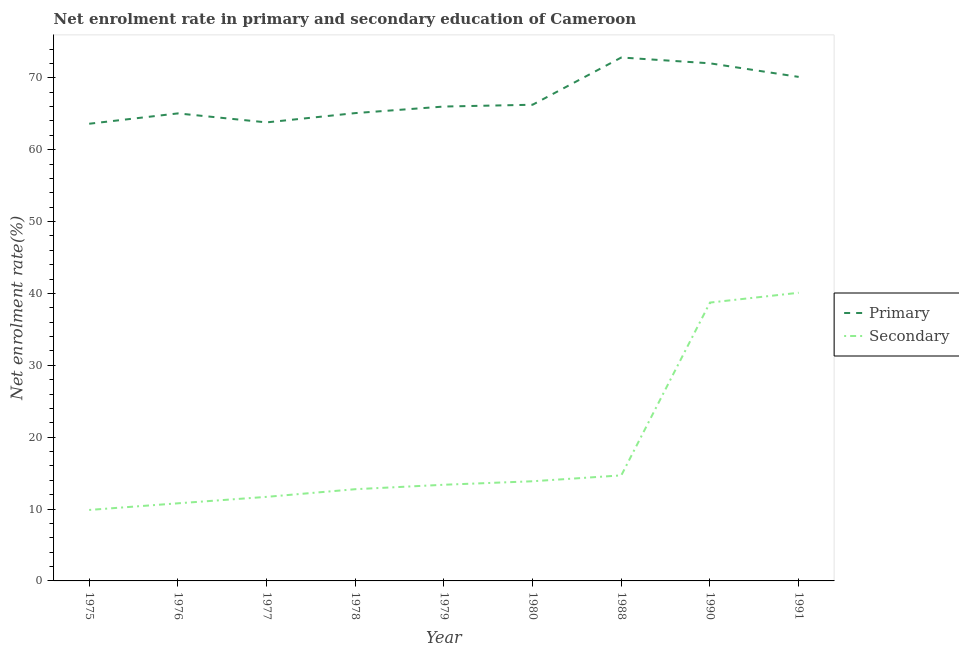How many different coloured lines are there?
Give a very brief answer. 2. Does the line corresponding to enrollment rate in secondary education intersect with the line corresponding to enrollment rate in primary education?
Make the answer very short. No. Is the number of lines equal to the number of legend labels?
Provide a succinct answer. Yes. What is the enrollment rate in secondary education in 1979?
Keep it short and to the point. 13.38. Across all years, what is the maximum enrollment rate in secondary education?
Ensure brevity in your answer.  40.09. Across all years, what is the minimum enrollment rate in secondary education?
Provide a short and direct response. 9.88. In which year was the enrollment rate in primary education minimum?
Keep it short and to the point. 1975. What is the total enrollment rate in secondary education in the graph?
Offer a terse response. 165.89. What is the difference between the enrollment rate in primary education in 1988 and that in 1990?
Keep it short and to the point. 0.81. What is the difference between the enrollment rate in primary education in 1978 and the enrollment rate in secondary education in 1980?
Ensure brevity in your answer.  51.23. What is the average enrollment rate in primary education per year?
Offer a very short reply. 67.2. In the year 1977, what is the difference between the enrollment rate in secondary education and enrollment rate in primary education?
Your answer should be compact. -52.1. In how many years, is the enrollment rate in primary education greater than 32 %?
Provide a succinct answer. 9. What is the ratio of the enrollment rate in primary education in 1976 to that in 1990?
Provide a succinct answer. 0.9. Is the difference between the enrollment rate in primary education in 1988 and 1990 greater than the difference between the enrollment rate in secondary education in 1988 and 1990?
Offer a terse response. Yes. What is the difference between the highest and the second highest enrollment rate in secondary education?
Offer a terse response. 1.36. What is the difference between the highest and the lowest enrollment rate in primary education?
Keep it short and to the point. 9.22. In how many years, is the enrollment rate in secondary education greater than the average enrollment rate in secondary education taken over all years?
Offer a terse response. 2. Does the enrollment rate in secondary education monotonically increase over the years?
Make the answer very short. Yes. Does the graph contain any zero values?
Keep it short and to the point. No. How are the legend labels stacked?
Your response must be concise. Vertical. What is the title of the graph?
Your answer should be compact. Net enrolment rate in primary and secondary education of Cameroon. Does "Nitrous oxide" appear as one of the legend labels in the graph?
Offer a very short reply. No. What is the label or title of the X-axis?
Offer a terse response. Year. What is the label or title of the Y-axis?
Provide a succinct answer. Net enrolment rate(%). What is the Net enrolment rate(%) in Primary in 1975?
Ensure brevity in your answer.  63.61. What is the Net enrolment rate(%) of Secondary in 1975?
Your answer should be very brief. 9.88. What is the Net enrolment rate(%) of Primary in 1976?
Provide a succinct answer. 65.05. What is the Net enrolment rate(%) of Secondary in 1976?
Keep it short and to the point. 10.8. What is the Net enrolment rate(%) in Primary in 1977?
Your response must be concise. 63.8. What is the Net enrolment rate(%) in Secondary in 1977?
Keep it short and to the point. 11.7. What is the Net enrolment rate(%) of Primary in 1978?
Your answer should be compact. 65.09. What is the Net enrolment rate(%) in Secondary in 1978?
Provide a short and direct response. 12.76. What is the Net enrolment rate(%) of Primary in 1979?
Offer a terse response. 66.01. What is the Net enrolment rate(%) in Secondary in 1979?
Offer a very short reply. 13.38. What is the Net enrolment rate(%) in Primary in 1980?
Offer a very short reply. 66.26. What is the Net enrolment rate(%) in Secondary in 1980?
Offer a terse response. 13.87. What is the Net enrolment rate(%) in Primary in 1988?
Offer a very short reply. 72.83. What is the Net enrolment rate(%) of Secondary in 1988?
Your answer should be very brief. 14.69. What is the Net enrolment rate(%) of Primary in 1990?
Ensure brevity in your answer.  72.02. What is the Net enrolment rate(%) of Secondary in 1990?
Offer a terse response. 38.73. What is the Net enrolment rate(%) of Primary in 1991?
Your answer should be compact. 70.13. What is the Net enrolment rate(%) in Secondary in 1991?
Your answer should be very brief. 40.09. Across all years, what is the maximum Net enrolment rate(%) in Primary?
Your answer should be compact. 72.83. Across all years, what is the maximum Net enrolment rate(%) in Secondary?
Offer a terse response. 40.09. Across all years, what is the minimum Net enrolment rate(%) of Primary?
Your answer should be compact. 63.61. Across all years, what is the minimum Net enrolment rate(%) in Secondary?
Give a very brief answer. 9.88. What is the total Net enrolment rate(%) of Primary in the graph?
Your response must be concise. 604.8. What is the total Net enrolment rate(%) in Secondary in the graph?
Offer a terse response. 165.89. What is the difference between the Net enrolment rate(%) of Primary in 1975 and that in 1976?
Give a very brief answer. -1.44. What is the difference between the Net enrolment rate(%) in Secondary in 1975 and that in 1976?
Provide a short and direct response. -0.92. What is the difference between the Net enrolment rate(%) of Primary in 1975 and that in 1977?
Your answer should be very brief. -0.19. What is the difference between the Net enrolment rate(%) of Secondary in 1975 and that in 1977?
Your answer should be compact. -1.82. What is the difference between the Net enrolment rate(%) of Primary in 1975 and that in 1978?
Your answer should be very brief. -1.48. What is the difference between the Net enrolment rate(%) of Secondary in 1975 and that in 1978?
Your answer should be very brief. -2.89. What is the difference between the Net enrolment rate(%) of Primary in 1975 and that in 1979?
Provide a short and direct response. -2.39. What is the difference between the Net enrolment rate(%) in Secondary in 1975 and that in 1979?
Your answer should be compact. -3.51. What is the difference between the Net enrolment rate(%) of Primary in 1975 and that in 1980?
Offer a terse response. -2.65. What is the difference between the Net enrolment rate(%) in Secondary in 1975 and that in 1980?
Your answer should be compact. -3.99. What is the difference between the Net enrolment rate(%) in Primary in 1975 and that in 1988?
Provide a succinct answer. -9.22. What is the difference between the Net enrolment rate(%) in Secondary in 1975 and that in 1988?
Your answer should be very brief. -4.81. What is the difference between the Net enrolment rate(%) in Primary in 1975 and that in 1990?
Give a very brief answer. -8.41. What is the difference between the Net enrolment rate(%) of Secondary in 1975 and that in 1990?
Your answer should be compact. -28.85. What is the difference between the Net enrolment rate(%) of Primary in 1975 and that in 1991?
Make the answer very short. -6.52. What is the difference between the Net enrolment rate(%) in Secondary in 1975 and that in 1991?
Ensure brevity in your answer.  -30.22. What is the difference between the Net enrolment rate(%) in Primary in 1976 and that in 1977?
Your answer should be very brief. 1.25. What is the difference between the Net enrolment rate(%) of Secondary in 1976 and that in 1977?
Offer a very short reply. -0.9. What is the difference between the Net enrolment rate(%) in Primary in 1976 and that in 1978?
Give a very brief answer. -0.04. What is the difference between the Net enrolment rate(%) in Secondary in 1976 and that in 1978?
Provide a succinct answer. -1.96. What is the difference between the Net enrolment rate(%) of Primary in 1976 and that in 1979?
Ensure brevity in your answer.  -0.95. What is the difference between the Net enrolment rate(%) of Secondary in 1976 and that in 1979?
Your answer should be compact. -2.58. What is the difference between the Net enrolment rate(%) in Primary in 1976 and that in 1980?
Keep it short and to the point. -1.21. What is the difference between the Net enrolment rate(%) of Secondary in 1976 and that in 1980?
Make the answer very short. -3.07. What is the difference between the Net enrolment rate(%) of Primary in 1976 and that in 1988?
Make the answer very short. -7.78. What is the difference between the Net enrolment rate(%) of Secondary in 1976 and that in 1988?
Keep it short and to the point. -3.89. What is the difference between the Net enrolment rate(%) of Primary in 1976 and that in 1990?
Offer a very short reply. -6.97. What is the difference between the Net enrolment rate(%) of Secondary in 1976 and that in 1990?
Provide a short and direct response. -27.93. What is the difference between the Net enrolment rate(%) of Primary in 1976 and that in 1991?
Your answer should be compact. -5.08. What is the difference between the Net enrolment rate(%) in Secondary in 1976 and that in 1991?
Ensure brevity in your answer.  -29.3. What is the difference between the Net enrolment rate(%) of Primary in 1977 and that in 1978?
Provide a succinct answer. -1.29. What is the difference between the Net enrolment rate(%) in Secondary in 1977 and that in 1978?
Ensure brevity in your answer.  -1.07. What is the difference between the Net enrolment rate(%) of Primary in 1977 and that in 1979?
Your response must be concise. -2.21. What is the difference between the Net enrolment rate(%) in Secondary in 1977 and that in 1979?
Give a very brief answer. -1.68. What is the difference between the Net enrolment rate(%) in Primary in 1977 and that in 1980?
Give a very brief answer. -2.46. What is the difference between the Net enrolment rate(%) in Secondary in 1977 and that in 1980?
Provide a short and direct response. -2.17. What is the difference between the Net enrolment rate(%) in Primary in 1977 and that in 1988?
Provide a short and direct response. -9.03. What is the difference between the Net enrolment rate(%) of Secondary in 1977 and that in 1988?
Your response must be concise. -2.99. What is the difference between the Net enrolment rate(%) of Primary in 1977 and that in 1990?
Ensure brevity in your answer.  -8.22. What is the difference between the Net enrolment rate(%) of Secondary in 1977 and that in 1990?
Offer a very short reply. -27.03. What is the difference between the Net enrolment rate(%) in Primary in 1977 and that in 1991?
Ensure brevity in your answer.  -6.33. What is the difference between the Net enrolment rate(%) in Secondary in 1977 and that in 1991?
Offer a terse response. -28.4. What is the difference between the Net enrolment rate(%) in Primary in 1978 and that in 1979?
Provide a short and direct response. -0.91. What is the difference between the Net enrolment rate(%) of Secondary in 1978 and that in 1979?
Your answer should be very brief. -0.62. What is the difference between the Net enrolment rate(%) of Primary in 1978 and that in 1980?
Offer a very short reply. -1.16. What is the difference between the Net enrolment rate(%) in Secondary in 1978 and that in 1980?
Provide a succinct answer. -1.11. What is the difference between the Net enrolment rate(%) in Primary in 1978 and that in 1988?
Keep it short and to the point. -7.74. What is the difference between the Net enrolment rate(%) in Secondary in 1978 and that in 1988?
Offer a terse response. -1.92. What is the difference between the Net enrolment rate(%) in Primary in 1978 and that in 1990?
Provide a short and direct response. -6.93. What is the difference between the Net enrolment rate(%) in Secondary in 1978 and that in 1990?
Keep it short and to the point. -25.97. What is the difference between the Net enrolment rate(%) of Primary in 1978 and that in 1991?
Keep it short and to the point. -5.04. What is the difference between the Net enrolment rate(%) in Secondary in 1978 and that in 1991?
Your response must be concise. -27.33. What is the difference between the Net enrolment rate(%) in Primary in 1979 and that in 1980?
Provide a short and direct response. -0.25. What is the difference between the Net enrolment rate(%) in Secondary in 1979 and that in 1980?
Make the answer very short. -0.49. What is the difference between the Net enrolment rate(%) in Primary in 1979 and that in 1988?
Offer a very short reply. -6.82. What is the difference between the Net enrolment rate(%) of Secondary in 1979 and that in 1988?
Your answer should be very brief. -1.31. What is the difference between the Net enrolment rate(%) in Primary in 1979 and that in 1990?
Your answer should be compact. -6.01. What is the difference between the Net enrolment rate(%) of Secondary in 1979 and that in 1990?
Offer a very short reply. -25.35. What is the difference between the Net enrolment rate(%) of Primary in 1979 and that in 1991?
Give a very brief answer. -4.12. What is the difference between the Net enrolment rate(%) in Secondary in 1979 and that in 1991?
Ensure brevity in your answer.  -26.71. What is the difference between the Net enrolment rate(%) in Primary in 1980 and that in 1988?
Your answer should be very brief. -6.57. What is the difference between the Net enrolment rate(%) in Secondary in 1980 and that in 1988?
Your answer should be compact. -0.82. What is the difference between the Net enrolment rate(%) in Primary in 1980 and that in 1990?
Provide a succinct answer. -5.76. What is the difference between the Net enrolment rate(%) in Secondary in 1980 and that in 1990?
Give a very brief answer. -24.86. What is the difference between the Net enrolment rate(%) of Primary in 1980 and that in 1991?
Provide a short and direct response. -3.87. What is the difference between the Net enrolment rate(%) in Secondary in 1980 and that in 1991?
Offer a terse response. -26.23. What is the difference between the Net enrolment rate(%) in Primary in 1988 and that in 1990?
Offer a terse response. 0.81. What is the difference between the Net enrolment rate(%) of Secondary in 1988 and that in 1990?
Your answer should be compact. -24.04. What is the difference between the Net enrolment rate(%) in Primary in 1988 and that in 1991?
Give a very brief answer. 2.7. What is the difference between the Net enrolment rate(%) of Secondary in 1988 and that in 1991?
Your response must be concise. -25.41. What is the difference between the Net enrolment rate(%) of Primary in 1990 and that in 1991?
Ensure brevity in your answer.  1.89. What is the difference between the Net enrolment rate(%) of Secondary in 1990 and that in 1991?
Your answer should be compact. -1.36. What is the difference between the Net enrolment rate(%) in Primary in 1975 and the Net enrolment rate(%) in Secondary in 1976?
Keep it short and to the point. 52.81. What is the difference between the Net enrolment rate(%) of Primary in 1975 and the Net enrolment rate(%) of Secondary in 1977?
Provide a short and direct response. 51.92. What is the difference between the Net enrolment rate(%) of Primary in 1975 and the Net enrolment rate(%) of Secondary in 1978?
Make the answer very short. 50.85. What is the difference between the Net enrolment rate(%) of Primary in 1975 and the Net enrolment rate(%) of Secondary in 1979?
Ensure brevity in your answer.  50.23. What is the difference between the Net enrolment rate(%) of Primary in 1975 and the Net enrolment rate(%) of Secondary in 1980?
Your answer should be very brief. 49.74. What is the difference between the Net enrolment rate(%) of Primary in 1975 and the Net enrolment rate(%) of Secondary in 1988?
Your answer should be compact. 48.93. What is the difference between the Net enrolment rate(%) of Primary in 1975 and the Net enrolment rate(%) of Secondary in 1990?
Provide a succinct answer. 24.88. What is the difference between the Net enrolment rate(%) in Primary in 1975 and the Net enrolment rate(%) in Secondary in 1991?
Offer a very short reply. 23.52. What is the difference between the Net enrolment rate(%) in Primary in 1976 and the Net enrolment rate(%) in Secondary in 1977?
Provide a short and direct response. 53.36. What is the difference between the Net enrolment rate(%) of Primary in 1976 and the Net enrolment rate(%) of Secondary in 1978?
Your answer should be compact. 52.29. What is the difference between the Net enrolment rate(%) in Primary in 1976 and the Net enrolment rate(%) in Secondary in 1979?
Offer a very short reply. 51.67. What is the difference between the Net enrolment rate(%) of Primary in 1976 and the Net enrolment rate(%) of Secondary in 1980?
Offer a very short reply. 51.18. What is the difference between the Net enrolment rate(%) of Primary in 1976 and the Net enrolment rate(%) of Secondary in 1988?
Provide a succinct answer. 50.37. What is the difference between the Net enrolment rate(%) in Primary in 1976 and the Net enrolment rate(%) in Secondary in 1990?
Offer a very short reply. 26.32. What is the difference between the Net enrolment rate(%) in Primary in 1976 and the Net enrolment rate(%) in Secondary in 1991?
Your answer should be compact. 24.96. What is the difference between the Net enrolment rate(%) in Primary in 1977 and the Net enrolment rate(%) in Secondary in 1978?
Make the answer very short. 51.04. What is the difference between the Net enrolment rate(%) in Primary in 1977 and the Net enrolment rate(%) in Secondary in 1979?
Your answer should be very brief. 50.42. What is the difference between the Net enrolment rate(%) in Primary in 1977 and the Net enrolment rate(%) in Secondary in 1980?
Ensure brevity in your answer.  49.93. What is the difference between the Net enrolment rate(%) of Primary in 1977 and the Net enrolment rate(%) of Secondary in 1988?
Ensure brevity in your answer.  49.11. What is the difference between the Net enrolment rate(%) in Primary in 1977 and the Net enrolment rate(%) in Secondary in 1990?
Provide a succinct answer. 25.07. What is the difference between the Net enrolment rate(%) of Primary in 1977 and the Net enrolment rate(%) of Secondary in 1991?
Provide a succinct answer. 23.71. What is the difference between the Net enrolment rate(%) in Primary in 1978 and the Net enrolment rate(%) in Secondary in 1979?
Keep it short and to the point. 51.71. What is the difference between the Net enrolment rate(%) of Primary in 1978 and the Net enrolment rate(%) of Secondary in 1980?
Offer a very short reply. 51.23. What is the difference between the Net enrolment rate(%) in Primary in 1978 and the Net enrolment rate(%) in Secondary in 1988?
Your answer should be compact. 50.41. What is the difference between the Net enrolment rate(%) of Primary in 1978 and the Net enrolment rate(%) of Secondary in 1990?
Ensure brevity in your answer.  26.36. What is the difference between the Net enrolment rate(%) in Primary in 1978 and the Net enrolment rate(%) in Secondary in 1991?
Your answer should be compact. 25. What is the difference between the Net enrolment rate(%) in Primary in 1979 and the Net enrolment rate(%) in Secondary in 1980?
Your answer should be compact. 52.14. What is the difference between the Net enrolment rate(%) in Primary in 1979 and the Net enrolment rate(%) in Secondary in 1988?
Your answer should be very brief. 51.32. What is the difference between the Net enrolment rate(%) in Primary in 1979 and the Net enrolment rate(%) in Secondary in 1990?
Your response must be concise. 27.28. What is the difference between the Net enrolment rate(%) of Primary in 1979 and the Net enrolment rate(%) of Secondary in 1991?
Give a very brief answer. 25.91. What is the difference between the Net enrolment rate(%) of Primary in 1980 and the Net enrolment rate(%) of Secondary in 1988?
Ensure brevity in your answer.  51.57. What is the difference between the Net enrolment rate(%) in Primary in 1980 and the Net enrolment rate(%) in Secondary in 1990?
Make the answer very short. 27.53. What is the difference between the Net enrolment rate(%) in Primary in 1980 and the Net enrolment rate(%) in Secondary in 1991?
Your answer should be compact. 26.16. What is the difference between the Net enrolment rate(%) of Primary in 1988 and the Net enrolment rate(%) of Secondary in 1990?
Make the answer very short. 34.1. What is the difference between the Net enrolment rate(%) of Primary in 1988 and the Net enrolment rate(%) of Secondary in 1991?
Give a very brief answer. 32.74. What is the difference between the Net enrolment rate(%) in Primary in 1990 and the Net enrolment rate(%) in Secondary in 1991?
Ensure brevity in your answer.  31.93. What is the average Net enrolment rate(%) of Primary per year?
Your response must be concise. 67.2. What is the average Net enrolment rate(%) in Secondary per year?
Make the answer very short. 18.43. In the year 1975, what is the difference between the Net enrolment rate(%) in Primary and Net enrolment rate(%) in Secondary?
Your answer should be compact. 53.74. In the year 1976, what is the difference between the Net enrolment rate(%) of Primary and Net enrolment rate(%) of Secondary?
Keep it short and to the point. 54.25. In the year 1977, what is the difference between the Net enrolment rate(%) in Primary and Net enrolment rate(%) in Secondary?
Make the answer very short. 52.1. In the year 1978, what is the difference between the Net enrolment rate(%) of Primary and Net enrolment rate(%) of Secondary?
Ensure brevity in your answer.  52.33. In the year 1979, what is the difference between the Net enrolment rate(%) in Primary and Net enrolment rate(%) in Secondary?
Your answer should be very brief. 52.62. In the year 1980, what is the difference between the Net enrolment rate(%) in Primary and Net enrolment rate(%) in Secondary?
Give a very brief answer. 52.39. In the year 1988, what is the difference between the Net enrolment rate(%) in Primary and Net enrolment rate(%) in Secondary?
Give a very brief answer. 58.14. In the year 1990, what is the difference between the Net enrolment rate(%) of Primary and Net enrolment rate(%) of Secondary?
Your response must be concise. 33.29. In the year 1991, what is the difference between the Net enrolment rate(%) of Primary and Net enrolment rate(%) of Secondary?
Provide a succinct answer. 30.04. What is the ratio of the Net enrolment rate(%) in Primary in 1975 to that in 1976?
Ensure brevity in your answer.  0.98. What is the ratio of the Net enrolment rate(%) of Secondary in 1975 to that in 1976?
Offer a very short reply. 0.91. What is the ratio of the Net enrolment rate(%) in Secondary in 1975 to that in 1977?
Offer a very short reply. 0.84. What is the ratio of the Net enrolment rate(%) of Primary in 1975 to that in 1978?
Offer a terse response. 0.98. What is the ratio of the Net enrolment rate(%) of Secondary in 1975 to that in 1978?
Give a very brief answer. 0.77. What is the ratio of the Net enrolment rate(%) in Primary in 1975 to that in 1979?
Offer a terse response. 0.96. What is the ratio of the Net enrolment rate(%) of Secondary in 1975 to that in 1979?
Provide a succinct answer. 0.74. What is the ratio of the Net enrolment rate(%) in Primary in 1975 to that in 1980?
Offer a terse response. 0.96. What is the ratio of the Net enrolment rate(%) of Secondary in 1975 to that in 1980?
Your answer should be very brief. 0.71. What is the ratio of the Net enrolment rate(%) of Primary in 1975 to that in 1988?
Your answer should be very brief. 0.87. What is the ratio of the Net enrolment rate(%) in Secondary in 1975 to that in 1988?
Ensure brevity in your answer.  0.67. What is the ratio of the Net enrolment rate(%) in Primary in 1975 to that in 1990?
Keep it short and to the point. 0.88. What is the ratio of the Net enrolment rate(%) of Secondary in 1975 to that in 1990?
Provide a succinct answer. 0.26. What is the ratio of the Net enrolment rate(%) in Primary in 1975 to that in 1991?
Give a very brief answer. 0.91. What is the ratio of the Net enrolment rate(%) in Secondary in 1975 to that in 1991?
Provide a short and direct response. 0.25. What is the ratio of the Net enrolment rate(%) of Primary in 1976 to that in 1977?
Offer a very short reply. 1.02. What is the ratio of the Net enrolment rate(%) of Secondary in 1976 to that in 1977?
Offer a very short reply. 0.92. What is the ratio of the Net enrolment rate(%) in Primary in 1976 to that in 1978?
Your response must be concise. 1. What is the ratio of the Net enrolment rate(%) in Secondary in 1976 to that in 1978?
Offer a terse response. 0.85. What is the ratio of the Net enrolment rate(%) in Primary in 1976 to that in 1979?
Provide a succinct answer. 0.99. What is the ratio of the Net enrolment rate(%) in Secondary in 1976 to that in 1979?
Offer a very short reply. 0.81. What is the ratio of the Net enrolment rate(%) of Primary in 1976 to that in 1980?
Ensure brevity in your answer.  0.98. What is the ratio of the Net enrolment rate(%) of Secondary in 1976 to that in 1980?
Provide a short and direct response. 0.78. What is the ratio of the Net enrolment rate(%) in Primary in 1976 to that in 1988?
Keep it short and to the point. 0.89. What is the ratio of the Net enrolment rate(%) in Secondary in 1976 to that in 1988?
Your answer should be very brief. 0.74. What is the ratio of the Net enrolment rate(%) in Primary in 1976 to that in 1990?
Provide a short and direct response. 0.9. What is the ratio of the Net enrolment rate(%) of Secondary in 1976 to that in 1990?
Provide a short and direct response. 0.28. What is the ratio of the Net enrolment rate(%) of Primary in 1976 to that in 1991?
Ensure brevity in your answer.  0.93. What is the ratio of the Net enrolment rate(%) in Secondary in 1976 to that in 1991?
Offer a very short reply. 0.27. What is the ratio of the Net enrolment rate(%) in Primary in 1977 to that in 1978?
Provide a succinct answer. 0.98. What is the ratio of the Net enrolment rate(%) in Secondary in 1977 to that in 1978?
Give a very brief answer. 0.92. What is the ratio of the Net enrolment rate(%) in Primary in 1977 to that in 1979?
Provide a succinct answer. 0.97. What is the ratio of the Net enrolment rate(%) in Secondary in 1977 to that in 1979?
Ensure brevity in your answer.  0.87. What is the ratio of the Net enrolment rate(%) in Primary in 1977 to that in 1980?
Provide a succinct answer. 0.96. What is the ratio of the Net enrolment rate(%) in Secondary in 1977 to that in 1980?
Ensure brevity in your answer.  0.84. What is the ratio of the Net enrolment rate(%) in Primary in 1977 to that in 1988?
Your answer should be very brief. 0.88. What is the ratio of the Net enrolment rate(%) in Secondary in 1977 to that in 1988?
Your response must be concise. 0.8. What is the ratio of the Net enrolment rate(%) in Primary in 1977 to that in 1990?
Provide a short and direct response. 0.89. What is the ratio of the Net enrolment rate(%) in Secondary in 1977 to that in 1990?
Your answer should be compact. 0.3. What is the ratio of the Net enrolment rate(%) of Primary in 1977 to that in 1991?
Your answer should be very brief. 0.91. What is the ratio of the Net enrolment rate(%) of Secondary in 1977 to that in 1991?
Offer a very short reply. 0.29. What is the ratio of the Net enrolment rate(%) in Primary in 1978 to that in 1979?
Provide a succinct answer. 0.99. What is the ratio of the Net enrolment rate(%) of Secondary in 1978 to that in 1979?
Offer a terse response. 0.95. What is the ratio of the Net enrolment rate(%) in Primary in 1978 to that in 1980?
Provide a succinct answer. 0.98. What is the ratio of the Net enrolment rate(%) of Secondary in 1978 to that in 1980?
Your response must be concise. 0.92. What is the ratio of the Net enrolment rate(%) of Primary in 1978 to that in 1988?
Make the answer very short. 0.89. What is the ratio of the Net enrolment rate(%) of Secondary in 1978 to that in 1988?
Your answer should be very brief. 0.87. What is the ratio of the Net enrolment rate(%) in Primary in 1978 to that in 1990?
Your response must be concise. 0.9. What is the ratio of the Net enrolment rate(%) of Secondary in 1978 to that in 1990?
Your response must be concise. 0.33. What is the ratio of the Net enrolment rate(%) in Primary in 1978 to that in 1991?
Offer a terse response. 0.93. What is the ratio of the Net enrolment rate(%) in Secondary in 1978 to that in 1991?
Offer a terse response. 0.32. What is the ratio of the Net enrolment rate(%) of Secondary in 1979 to that in 1980?
Give a very brief answer. 0.96. What is the ratio of the Net enrolment rate(%) of Primary in 1979 to that in 1988?
Provide a short and direct response. 0.91. What is the ratio of the Net enrolment rate(%) of Secondary in 1979 to that in 1988?
Your response must be concise. 0.91. What is the ratio of the Net enrolment rate(%) in Primary in 1979 to that in 1990?
Offer a very short reply. 0.92. What is the ratio of the Net enrolment rate(%) in Secondary in 1979 to that in 1990?
Make the answer very short. 0.35. What is the ratio of the Net enrolment rate(%) of Secondary in 1979 to that in 1991?
Keep it short and to the point. 0.33. What is the ratio of the Net enrolment rate(%) in Primary in 1980 to that in 1988?
Your answer should be compact. 0.91. What is the ratio of the Net enrolment rate(%) of Secondary in 1980 to that in 1988?
Your response must be concise. 0.94. What is the ratio of the Net enrolment rate(%) in Secondary in 1980 to that in 1990?
Ensure brevity in your answer.  0.36. What is the ratio of the Net enrolment rate(%) of Primary in 1980 to that in 1991?
Provide a succinct answer. 0.94. What is the ratio of the Net enrolment rate(%) in Secondary in 1980 to that in 1991?
Provide a succinct answer. 0.35. What is the ratio of the Net enrolment rate(%) in Primary in 1988 to that in 1990?
Your answer should be very brief. 1.01. What is the ratio of the Net enrolment rate(%) of Secondary in 1988 to that in 1990?
Provide a succinct answer. 0.38. What is the ratio of the Net enrolment rate(%) of Primary in 1988 to that in 1991?
Make the answer very short. 1.04. What is the ratio of the Net enrolment rate(%) in Secondary in 1988 to that in 1991?
Ensure brevity in your answer.  0.37. What is the difference between the highest and the second highest Net enrolment rate(%) of Primary?
Your answer should be compact. 0.81. What is the difference between the highest and the second highest Net enrolment rate(%) of Secondary?
Your response must be concise. 1.36. What is the difference between the highest and the lowest Net enrolment rate(%) of Primary?
Make the answer very short. 9.22. What is the difference between the highest and the lowest Net enrolment rate(%) of Secondary?
Offer a terse response. 30.22. 